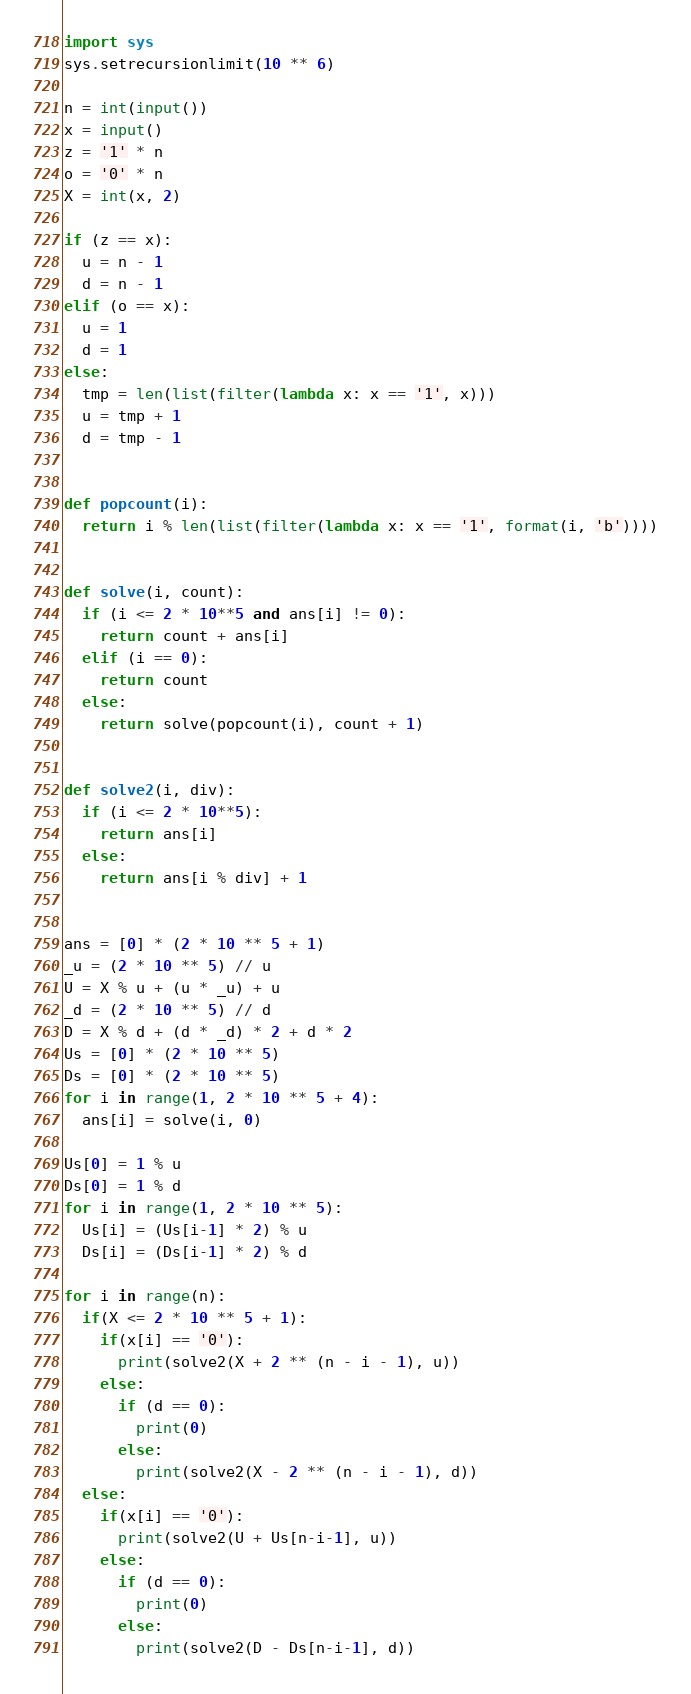<code> <loc_0><loc_0><loc_500><loc_500><_Python_>import sys
sys.setrecursionlimit(10 ** 6)

n = int(input())
x = input()
z = '1' * n
o = '0' * n
X = int(x, 2)

if (z == x):
  u = n - 1
  d = n - 1
elif (o == x):
  u = 1
  d = 1
else:
  tmp = len(list(filter(lambda x: x == '1', x)))
  u = tmp + 1
  d = tmp - 1


def popcount(i):
  return i % len(list(filter(lambda x: x == '1', format(i, 'b'))))


def solve(i, count):
  if (i <= 2 * 10**5 and ans[i] != 0):
    return count + ans[i]
  elif (i == 0):
    return count
  else:
    return solve(popcount(i), count + 1)


def solve2(i, div):
  if (i <= 2 * 10**5):
    return ans[i]
  else:
    return ans[i % div] + 1


ans = [0] * (2 * 10 ** 5 + 1)
_u = (2 * 10 ** 5) // u
U = X % u + (u * _u) + u
_d = (2 * 10 ** 5) // d
D = X % d + (d * _d) * 2 + d * 2
Us = [0] * (2 * 10 ** 5)
Ds = [0] * (2 * 10 ** 5)
for i in range(1, 2 * 10 ** 5 + 4):
  ans[i] = solve(i, 0)
  
Us[0] = 1 % u
Ds[0] = 1 % d
for i in range(1, 2 * 10 ** 5):
  Us[i] = (Us[i-1] * 2) % u
  Ds[i] = (Ds[i-1] * 2) % d

for i in range(n):
  if(X <= 2 * 10 ** 5 + 1):
    if(x[i] == '0'):
      print(solve2(X + 2 ** (n - i - 1), u))
    else:
      if (d == 0):
        print(0)
      else:
        print(solve2(X - 2 ** (n - i - 1), d))
  else:
    if(x[i] == '0'):
      print(solve2(U + Us[n-i-1], u))
    else:
      if (d == 0):
        print(0)
      else:
        print(solve2(D - Ds[n-i-1], d))
</code> 